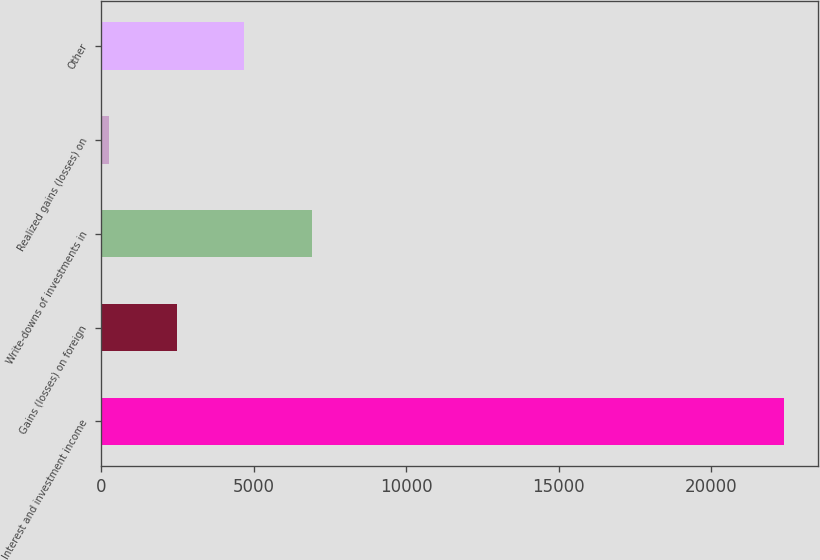Convert chart to OTSL. <chart><loc_0><loc_0><loc_500><loc_500><bar_chart><fcel>Interest and investment income<fcel>Gains (losses) on foreign<fcel>Write-downs of investments in<fcel>Realized gains (losses) on<fcel>Other<nl><fcel>22397<fcel>2476.4<fcel>6903.2<fcel>263<fcel>4689.8<nl></chart> 